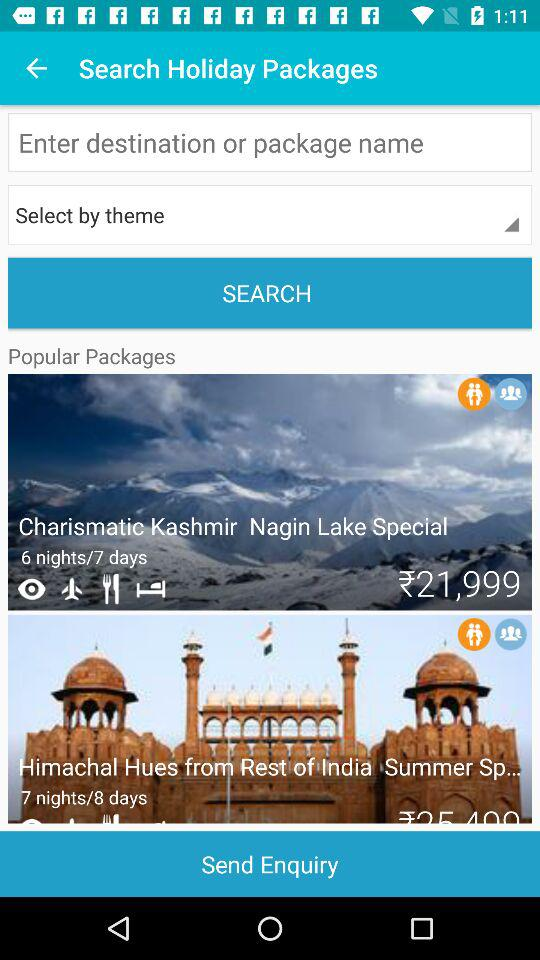Can you tell me about the main attractions in the 'Charismatic Kashmir' package? The 'Charismatic Kashmir' package likely includes iconic attractions such as the serene Nagin Lake, the beautiful Mughal Gardens, the historic Dal Lake with its famous houseboats, and perhaps a visit to Gulmarg and Pahalgam, known for their scenic beauty and opportunities for adventure sports. 